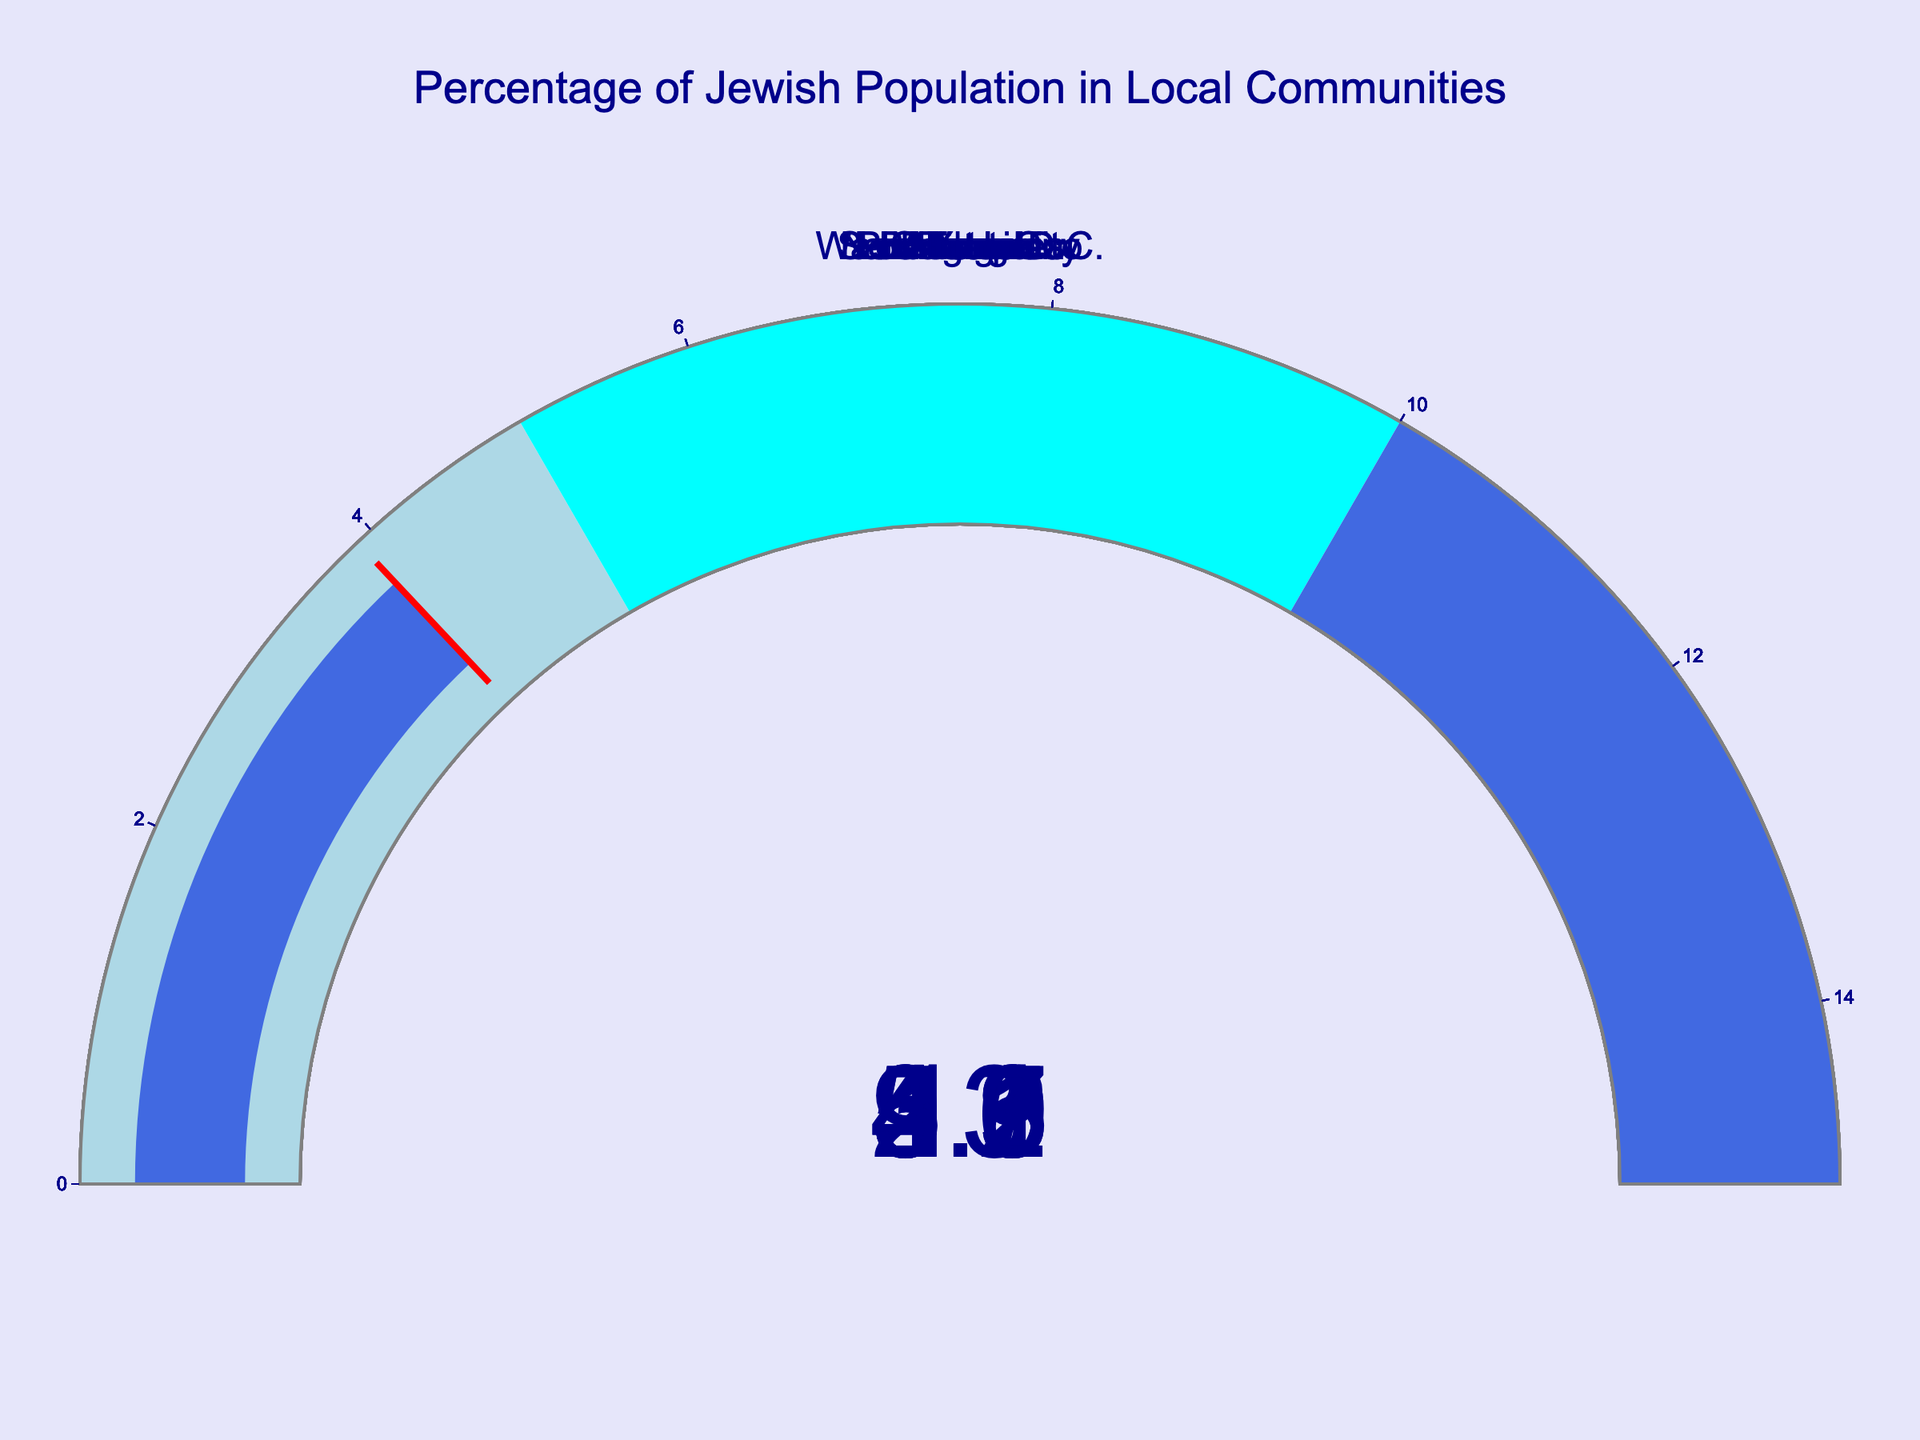What is the percentage of the Jewish population in New York City? The gauge chart for New York City shows a value of 13%.
Answer: 13% Which city has the lowest percentage of the Jewish population? By looking at the gauge charts, the city with the lowest percentage is Chicago with 2.9%.
Answer: Chicago Which cities have a Jewish population percentage greater than 5%? From the figure, the cities with percentages greater than 5% are New York City (13%), Miami (9.5%), Boston (5.6%), and Los Angeles (5.1%).
Answer: New York City, Miami, Boston, Los Angeles What is the average percentage of the Jewish population across all the cities? First, sum the percentages: 13 + 5.1 + 2.9 + 9.5 + 5.6 + 4.2 + 4.3 + 3.7 + 3.3 + 3.9 = 55.5. Then, divide by the number of cities (10). The average is 55.5 / 10 = 5.55%.
Answer: 5.55% Which city has the closest Jewish population percentage to the average percentage? The average percentage is 5.55%. The closest values are from Boston (5.6%) and Los Angeles (5.1%). The closest is Boston with 5.6%.
Answer: Boston How many cities have a Jewish population percentage below 4%? Cities below 4% in the figure are Chicago (2.9%), San Francisco (3.7%), Atlanta (3.3%), and Baltimore (3.9%). There are 4 cities.
Answer: 4 By how much does Miami's Jewish population percentage exceed that of Philadelphia? Miami has 9.5% and Philadelphia has 4.2%. The difference is 9.5 - 4.2 = 5.3%.
Answer: 5.3% What is the total percentage of Jewish populations in New York City and Miami? Summing the percentages of New York City (13%) and Miami (9.5%), the total is 13 + 9.5 = 22.5%.
Answer: 22.5% Which city has a Jewish population percentage within the range of 3% to 4%? Cities within 3% to 4% are San Francisco (3.7%), Atlanta (3.3%), and Baltimore (3.9%).
Answer: San Francisco, Atlanta, Baltimore 